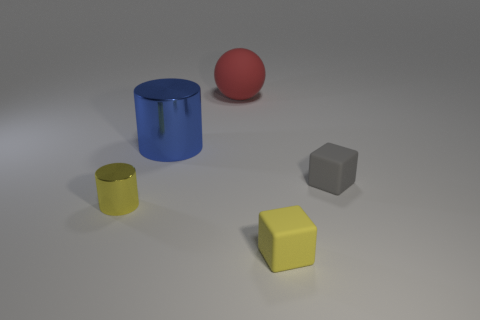Add 5 tiny rubber cubes. How many objects exist? 10 Subtract all blocks. How many objects are left? 3 Add 3 small yellow cylinders. How many small yellow cylinders exist? 4 Subtract 0 red cubes. How many objects are left? 5 Subtract all tiny gray rubber things. Subtract all small gray shiny cubes. How many objects are left? 4 Add 2 small yellow rubber things. How many small yellow rubber things are left? 3 